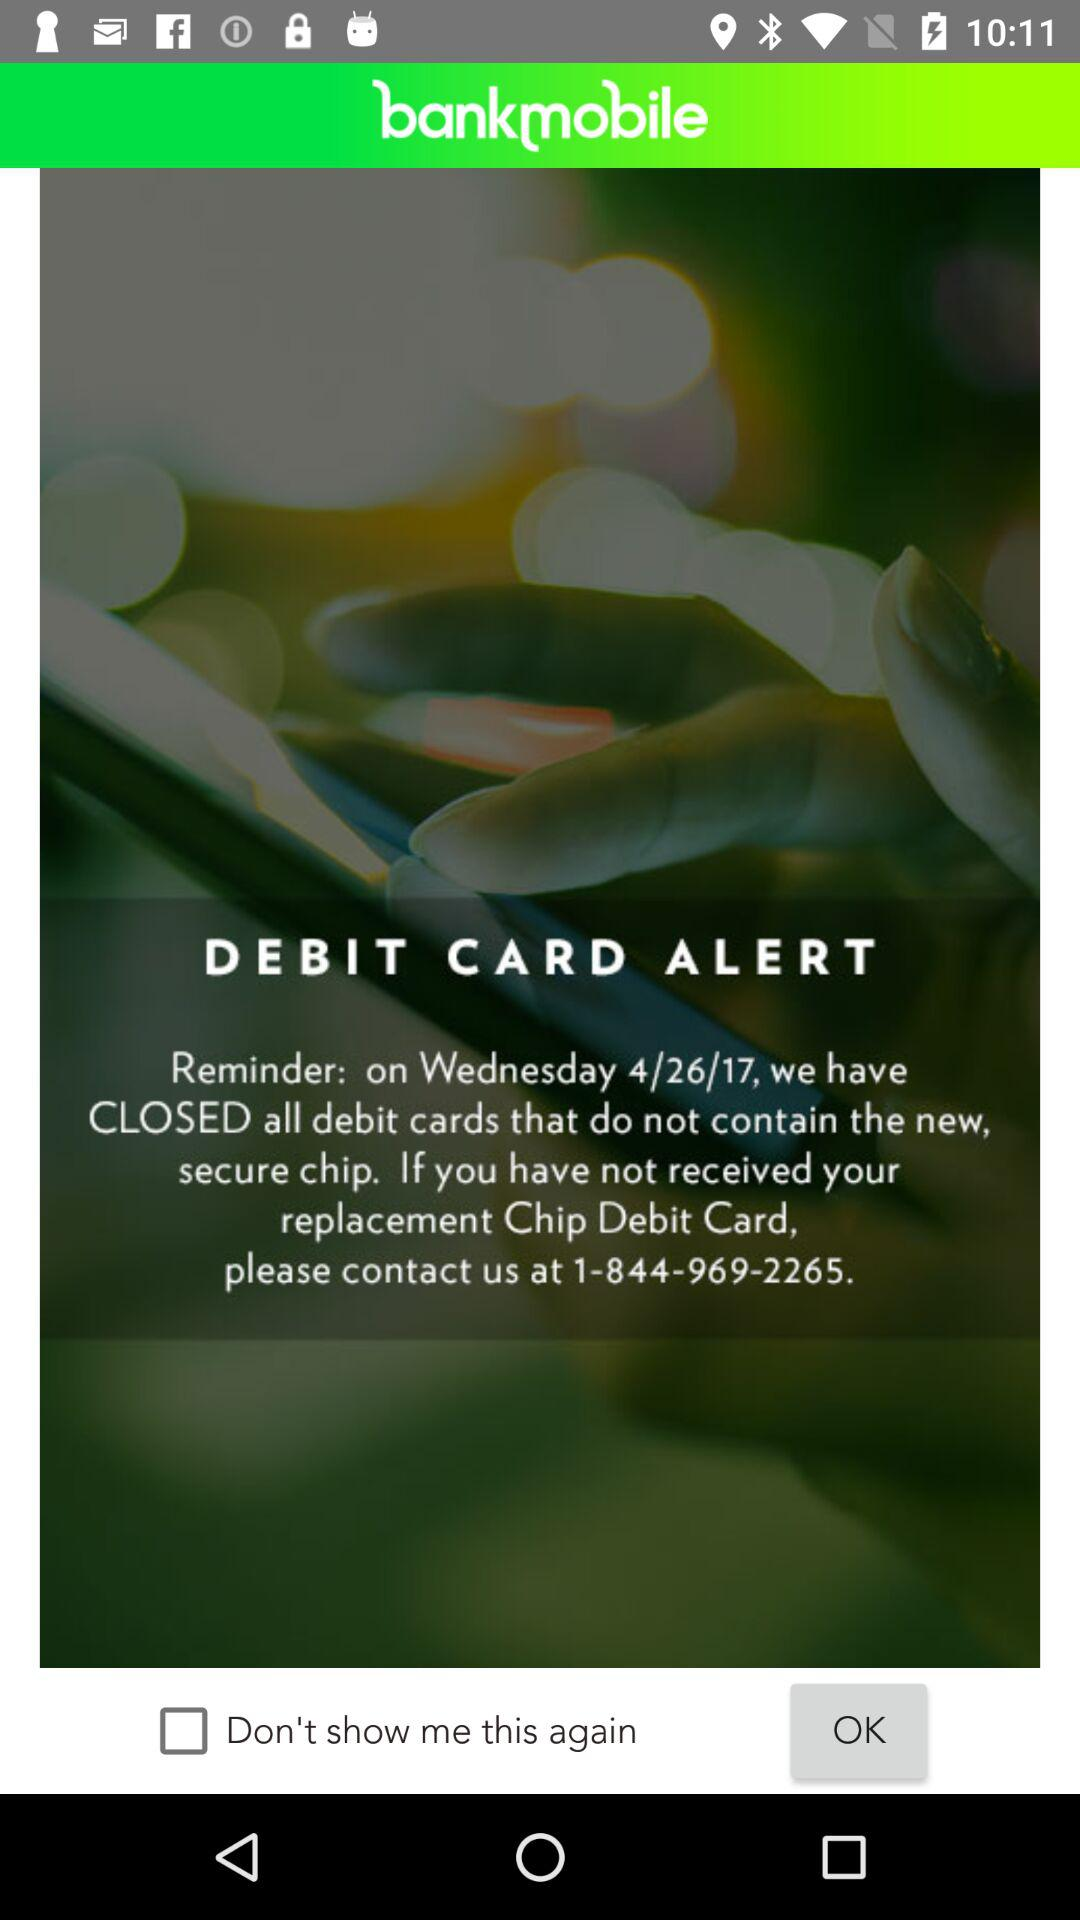On what date were all debit cards closed? All debit cards were closed on Wednesday, 4/26/17. 